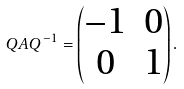<formula> <loc_0><loc_0><loc_500><loc_500>Q A Q ^ { - 1 } = \begin{pmatrix} - 1 & 0 \\ 0 & 1 \end{pmatrix} .</formula> 